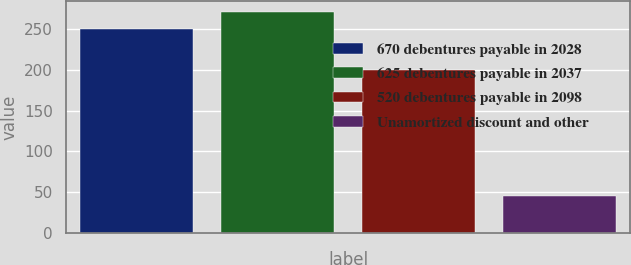Convert chart. <chart><loc_0><loc_0><loc_500><loc_500><bar_chart><fcel>670 debentures payable in 2028<fcel>625 debentures payable in 2037<fcel>520 debentures payable in 2098<fcel>Unamortized discount and other<nl><fcel>250<fcel>270.49<fcel>200<fcel>45.1<nl></chart> 